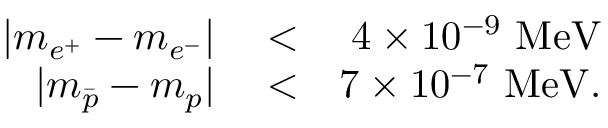<formula> <loc_0><loc_0><loc_500><loc_500>\begin{array} { r l r } { | m _ { e ^ { + } } - m _ { e ^ { - } } | } & < } & { 4 \times 1 0 ^ { - 9 } M e V } \\ { | m _ { \bar { p } } - m _ { p } | } & < } & { 7 \times 1 0 ^ { - 7 } M e V . } \end{array}</formula> 